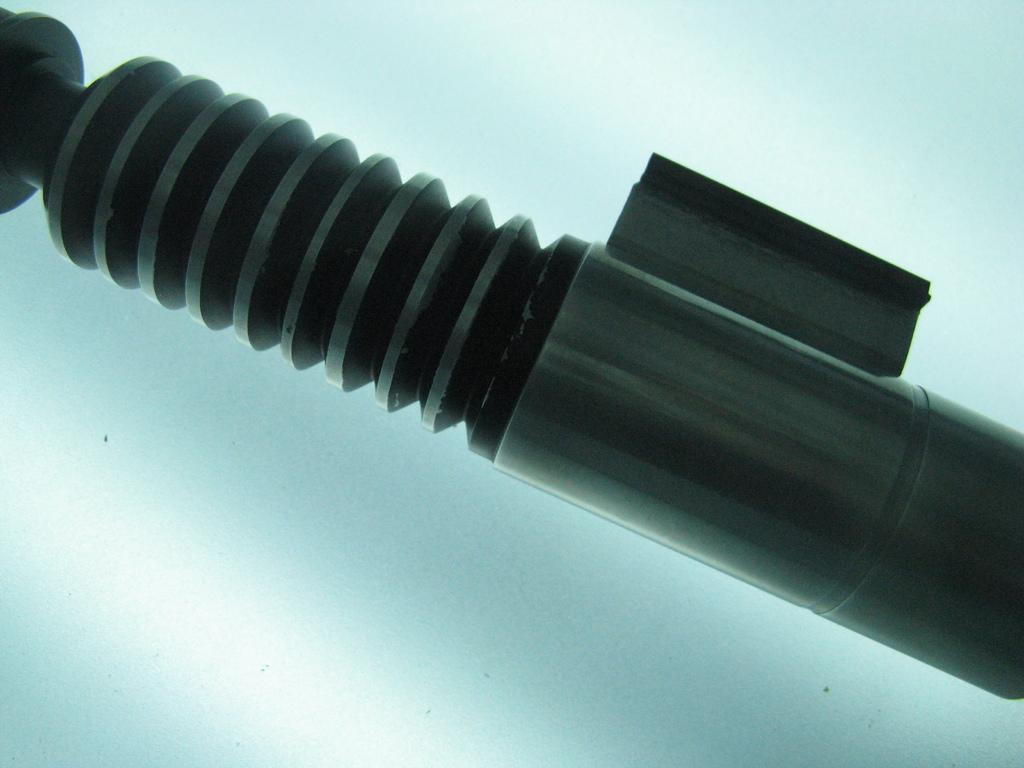What is the color of the object in the image? The object in the image is black. Can you see a toad sitting on the black object in the image? There is no toad present in the image. 